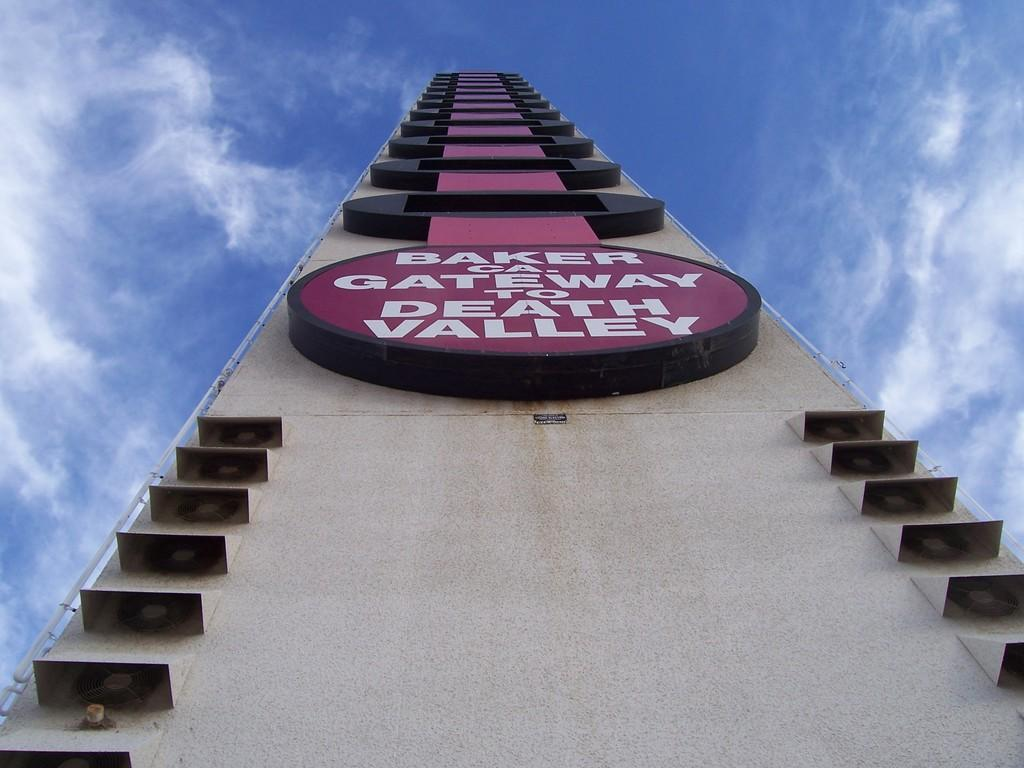What type of structure is visible in the image? There is a building in the image. What can be seen in the background of the image? There is a sky visible in the background of the image. What is the condition of the sky in the image? Clouds are present in the sky. Can you tell me how many times the building kicks the clouds in the image? Buildings do not kick clouds, as they are inanimate objects. The image does not depict any such action. 